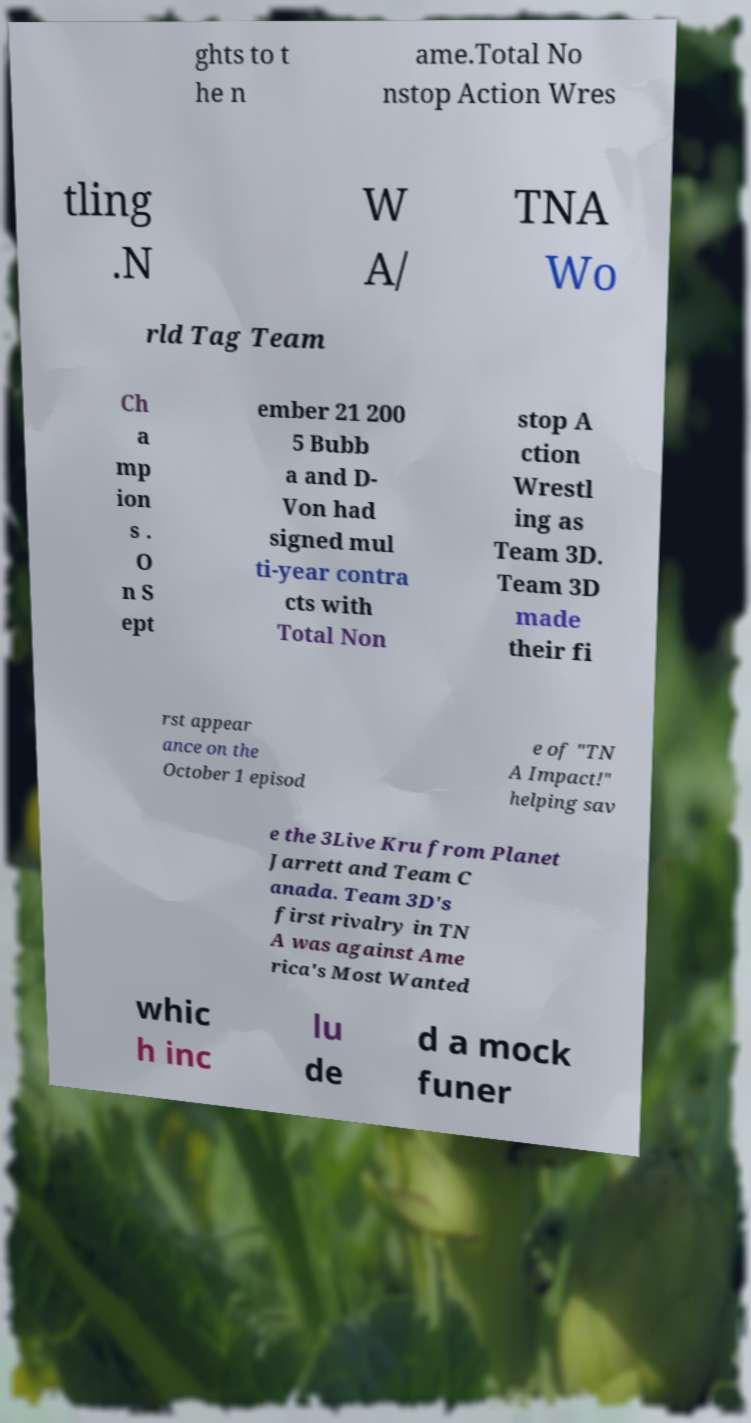Could you assist in decoding the text presented in this image and type it out clearly? ghts to t he n ame.Total No nstop Action Wres tling .N W A/ TNA Wo rld Tag Team Ch a mp ion s . O n S ept ember 21 200 5 Bubb a and D- Von had signed mul ti-year contra cts with Total Non stop A ction Wrestl ing as Team 3D. Team 3D made their fi rst appear ance on the October 1 episod e of "TN A Impact!" helping sav e the 3Live Kru from Planet Jarrett and Team C anada. Team 3D's first rivalry in TN A was against Ame rica's Most Wanted whic h inc lu de d a mock funer 